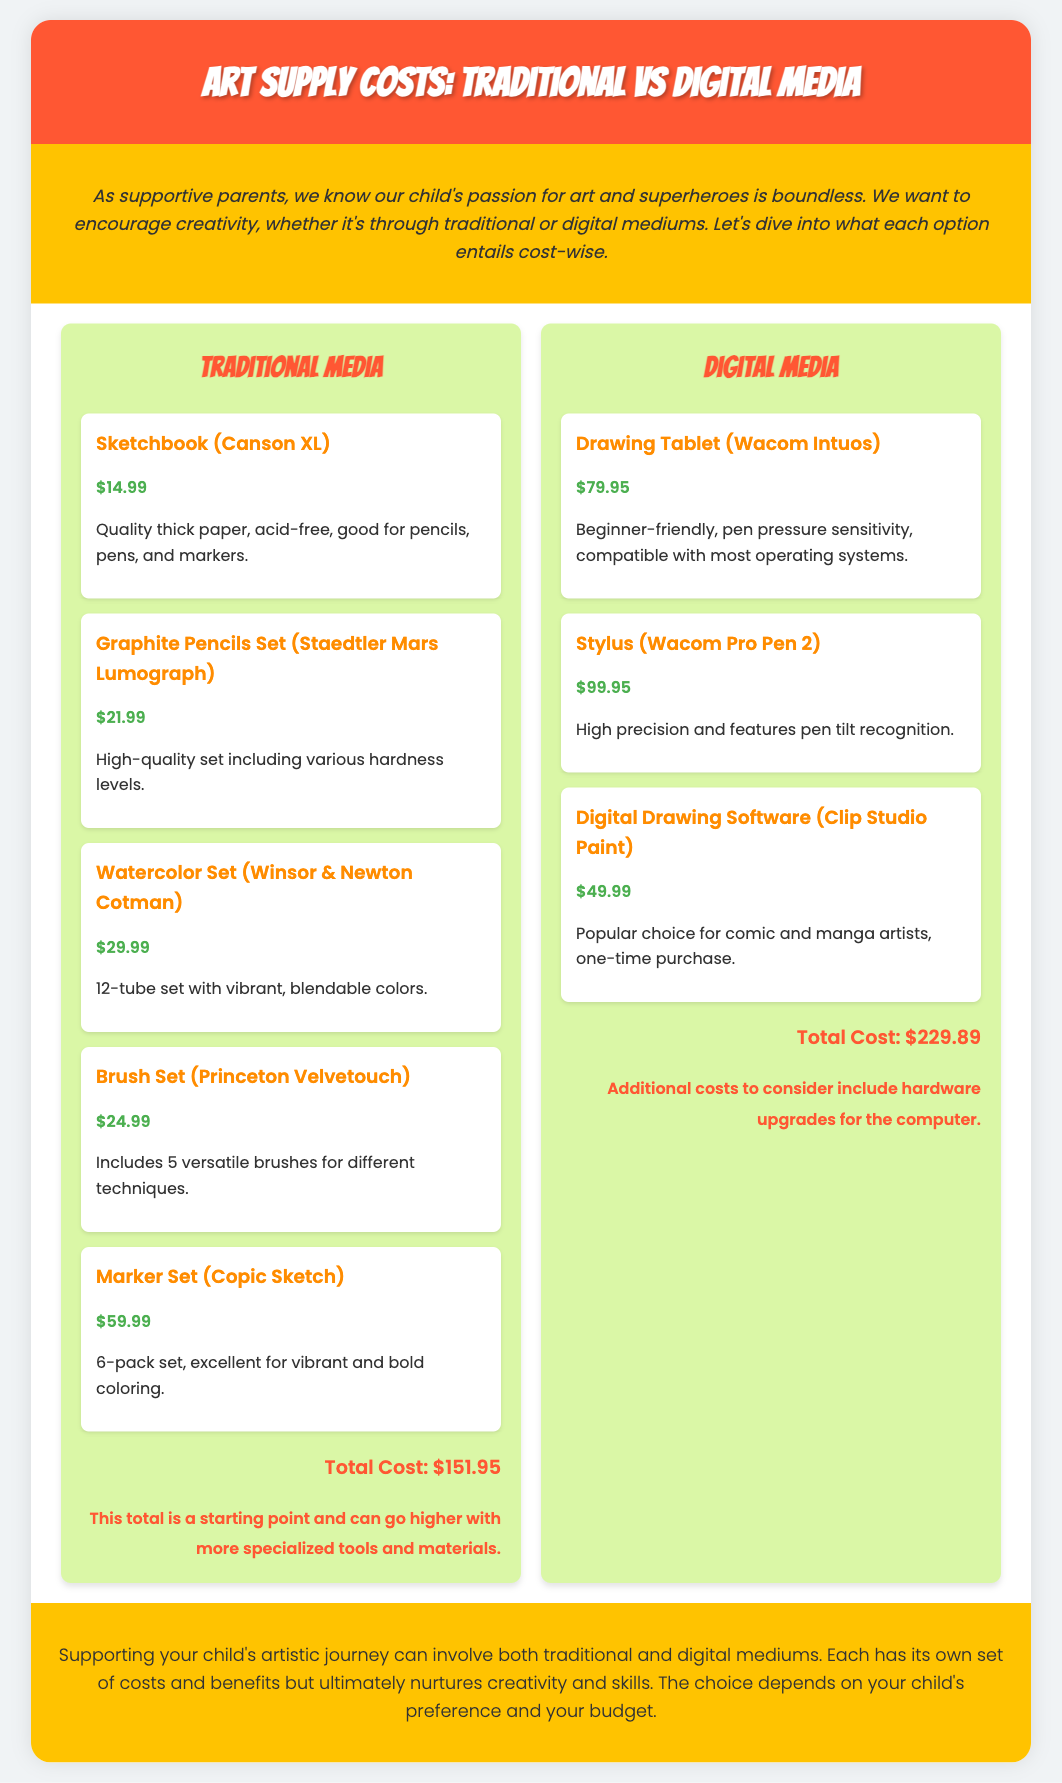What is the total cost for Traditional Media supplies? The total cost for Traditional Media supplies is listed at the bottom of the section, which is $151.95.
Answer: $151.95 What brand is the Graphite Pencils Set? The brand of the Graphite Pencils Set mentioned is Staedtler Mars Lumograph.
Answer: Staedtler Mars Lumograph How much does the Digital Drawing Software cost? The cost of the Digital Drawing Software (Clip Studio Paint) is provided in the document as $49.99.
Answer: $49.99 What is included in the Brush Set for Traditional Media? The Brush Set includes 5 versatile brushes for different techniques.
Answer: 5 versatile brushes Which media type has a higher total cost? By comparing the total costs listed for Traditional and Digital Media, Digital Media costs more overall at $229.89.
Answer: Digital Media What is the price of the Wacom Intuos Drawing Tablet? The price of the Wacom Intuos Drawing Tablet is stated as $79.95 in the Digital Media section.
Answer: $79.95 What additional costs might come with Digital Media? The document mentions that additional costs for Digital Media include hardware upgrades for the computer.
Answer: Hardware upgrades What is the main theme of the document? The main theme of the document is a comparison between the costs of Traditional and Digital Art Supplies.
Answer: Cost comparison What color is the background of the conclusion section? The conclusion section has a background color of #FFC300.
Answer: #FFC300 Which art supply type contains 12 tubes? The Watercolor Set includes 12 tubes of vibrant colors.
Answer: Watercolor Set 